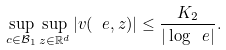<formula> <loc_0><loc_0><loc_500><loc_500>\sup _ { c \in \mathcal { B } _ { 1 } } \sup _ { z \in \mathbb { R } ^ { d } } | v ( \ e , z ) | \leq \frac { K _ { 2 } } { | \log \ e | } .</formula> 